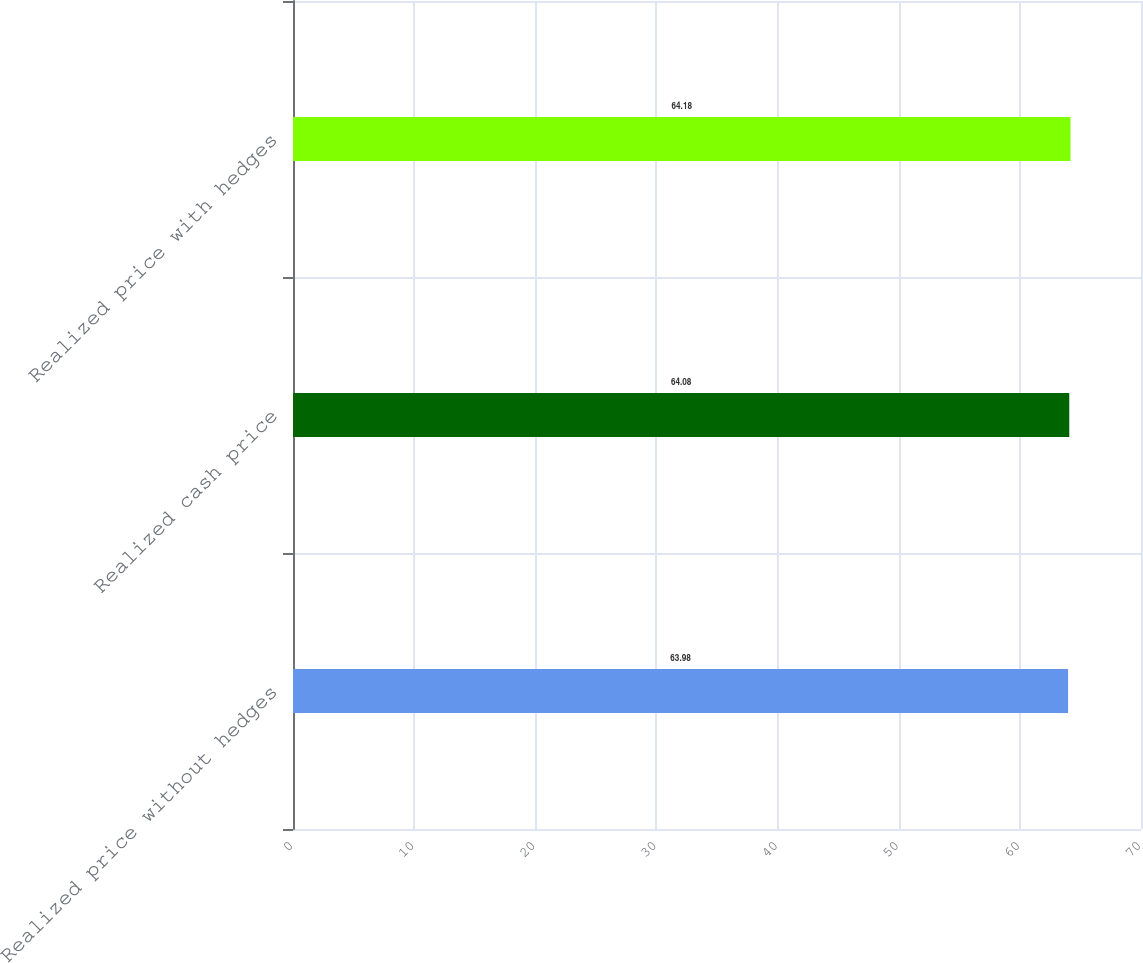<chart> <loc_0><loc_0><loc_500><loc_500><bar_chart><fcel>Realized price without hedges<fcel>Realized cash price<fcel>Realized price with hedges<nl><fcel>63.98<fcel>64.08<fcel>64.18<nl></chart> 